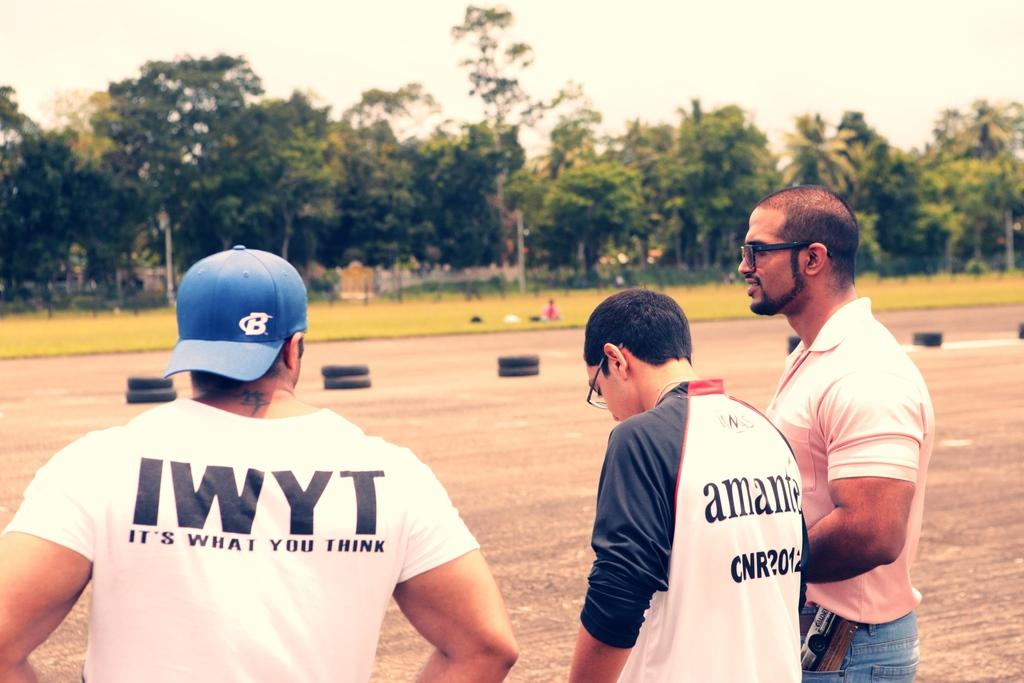<image>
Relay a brief, clear account of the picture shown. Man wearing a white shirt that says IWYT on it. 